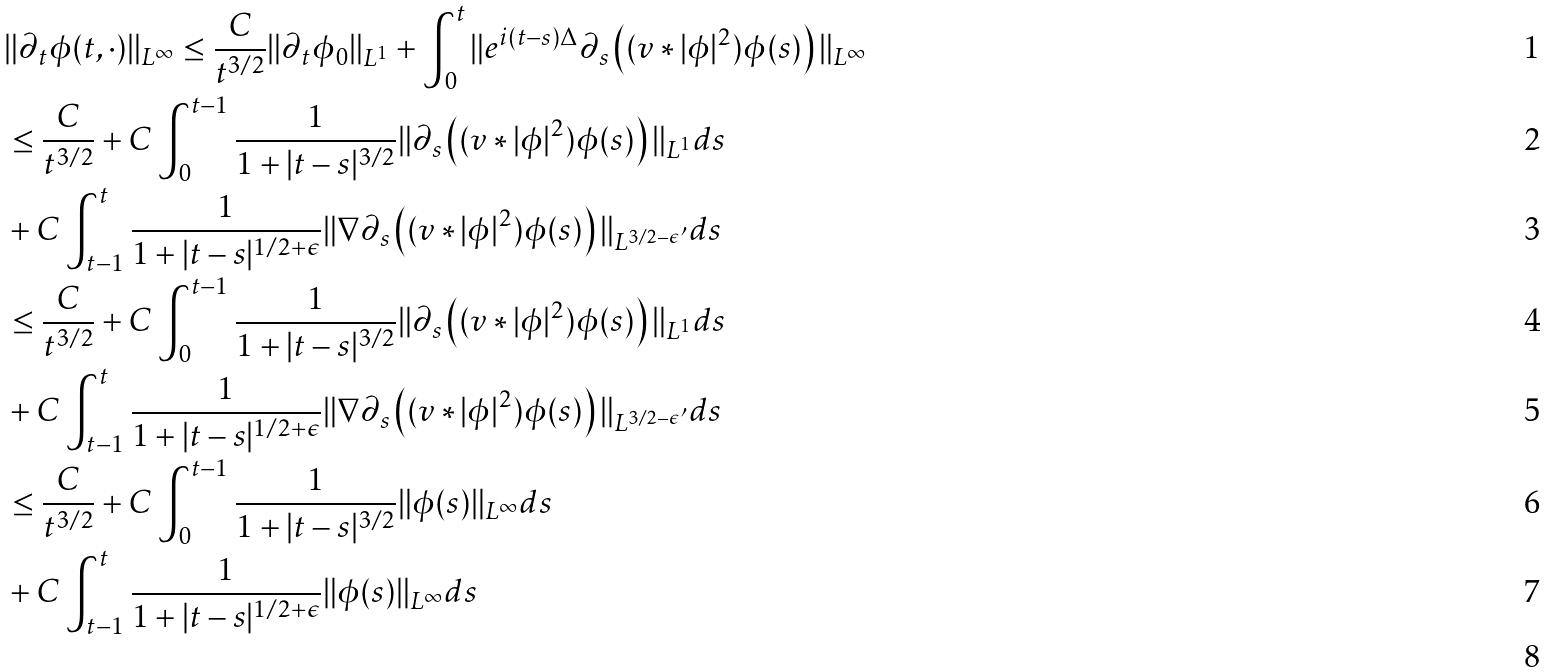Convert formula to latex. <formula><loc_0><loc_0><loc_500><loc_500>& \| \partial _ { t } \phi ( t , \cdot ) \| _ { L ^ { \infty } } \leq \frac { C } { t ^ { 3 / 2 } } \| \partial _ { t } \phi _ { 0 } \| _ { L ^ { 1 } } + \int _ { 0 } ^ { t } \| e ^ { i ( t - s ) \Delta } \partial _ { s } \left ( ( v * | \phi | ^ { 2 } ) \phi ( s ) \right ) \| _ { L ^ { \infty } } \\ & \leq \frac { C } { t ^ { 3 / 2 } } + C \int _ { 0 } ^ { t - 1 } \frac { 1 } { 1 + | t - s | ^ { 3 / 2 } } \| \partial _ { s } \left ( ( v * | \phi | ^ { 2 } ) \phi ( s ) \right ) \| _ { L ^ { 1 } } d s \\ & + C \int _ { t - 1 } ^ { t } \frac { 1 } { 1 + | t - s | ^ { 1 / 2 + \epsilon } } \| \nabla \partial _ { s } \left ( ( v * | \phi | ^ { 2 } ) \phi ( s ) \right ) \| _ { L ^ { 3 / 2 - \epsilon ^ { \prime } } } d s \\ & \leq \frac { C } { t ^ { 3 / 2 } } + C \int _ { 0 } ^ { t - 1 } \frac { 1 } { 1 + | t - s | ^ { 3 / 2 } } \| \partial _ { s } \left ( ( v * | \phi | ^ { 2 } ) \phi ( s ) \right ) \| _ { L ^ { 1 } } d s \\ & + C \int _ { t - 1 } ^ { t } \frac { 1 } { 1 + | t - s | ^ { 1 / 2 + \epsilon } } \| \nabla \partial _ { s } \left ( ( v * | \phi | ^ { 2 } ) \phi ( s ) \right ) \| _ { L ^ { 3 / 2 - \epsilon ^ { \prime } } } d s \\ & \leq \frac { C } { t ^ { 3 / 2 } } + C \int _ { 0 } ^ { t - 1 } \frac { 1 } { 1 + | t - s | ^ { 3 / 2 } } \| \phi ( s ) \| _ { L ^ { \infty } } d s \\ & + C \int _ { t - 1 } ^ { t } \frac { 1 } { 1 + | t - s | ^ { 1 / 2 + \epsilon } } \| \phi ( s ) \| _ { L ^ { \infty } } d s \\</formula> 